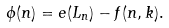<formula> <loc_0><loc_0><loc_500><loc_500>\phi ( n ) = e ( L _ { n } ) - f ( n , k ) .</formula> 